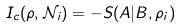<formula> <loc_0><loc_0><loc_500><loc_500>I _ { c } ( \rho , \mathcal { N } _ { i } ) = - S ( A | B , \rho _ { i } )</formula> 